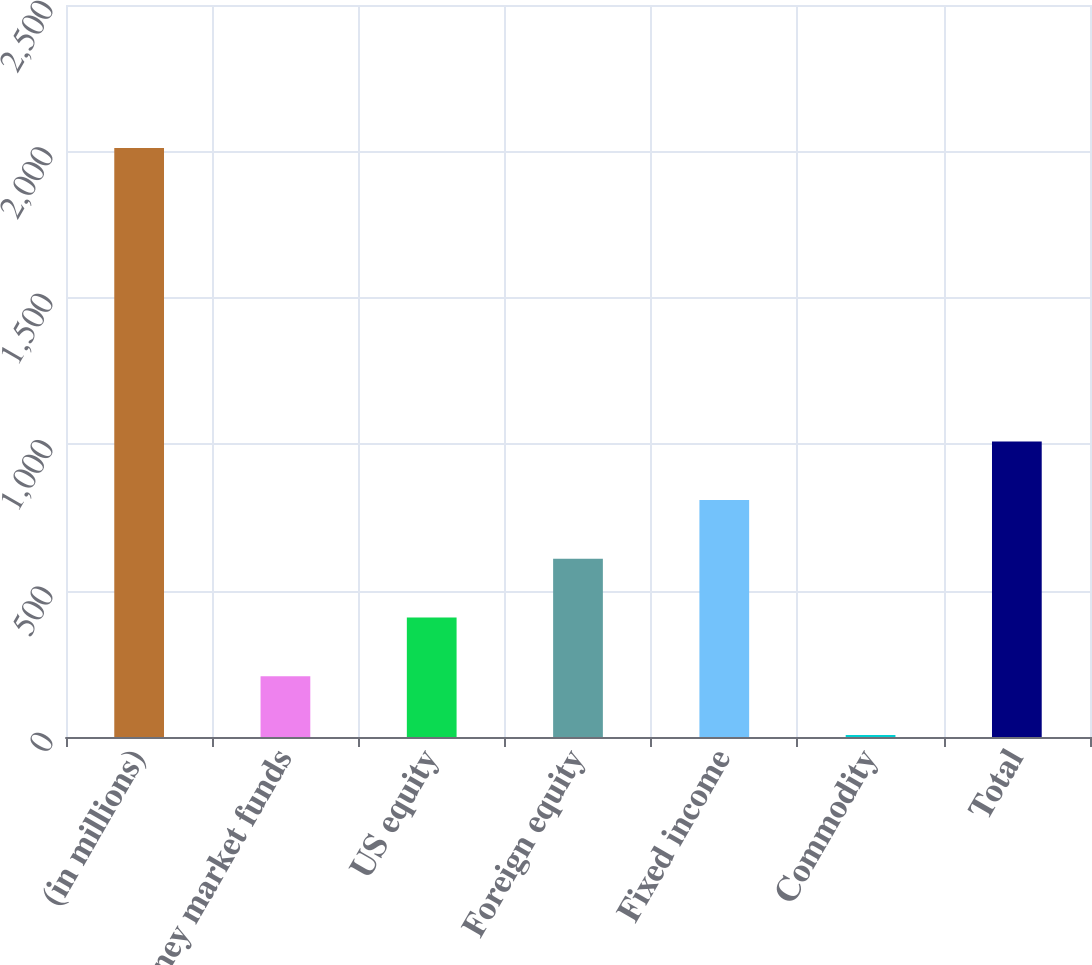<chart> <loc_0><loc_0><loc_500><loc_500><bar_chart><fcel>(in millions)<fcel>Money market funds<fcel>US equity<fcel>Foreign equity<fcel>Fixed income<fcel>Commodity<fcel>Total<nl><fcel>2012<fcel>207.68<fcel>408.16<fcel>608.64<fcel>809.12<fcel>7.2<fcel>1009.6<nl></chart> 